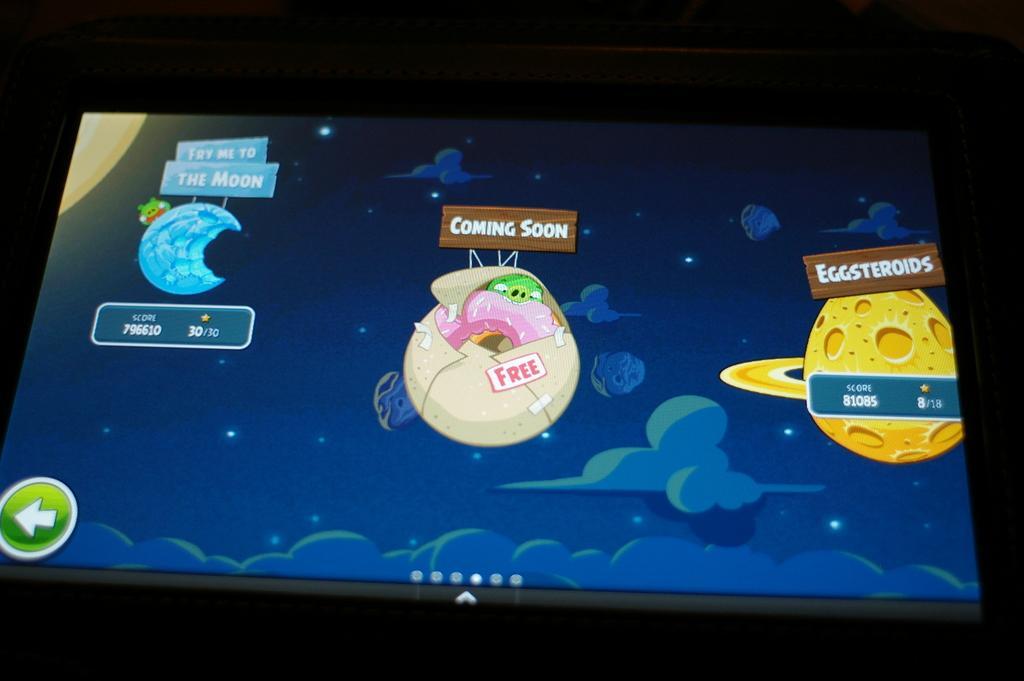Can you describe this image briefly? In this picture we can observe a screen. In the screen we can see some cartoon images which were in yellow, cream and blue in color. In the background there is a space. 